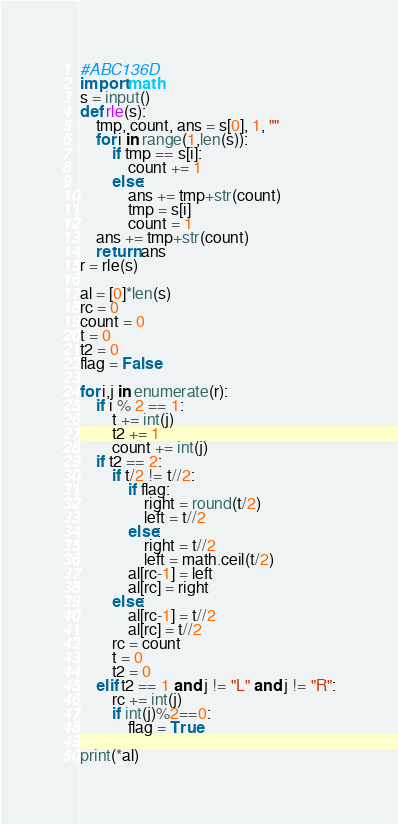<code> <loc_0><loc_0><loc_500><loc_500><_Python_>#ABC136D
import math
s = input()
def rle(s):
    tmp, count, ans = s[0], 1, ""
    for i in range(1,len(s)):
        if tmp == s[i]:
            count += 1
        else:
            ans += tmp+str(count)
            tmp = s[i]
            count = 1
    ans += tmp+str(count)
    return ans
r = rle(s)

al = [0]*len(s)
rc = 0
count = 0
t = 0
t2 = 0
flag = False

for i,j in enumerate(r):
    if i % 2 == 1:
        t += int(j)
        t2 += 1
        count += int(j)
    if t2 == 2:
        if t/2 != t//2:
            if flag:
                right = round(t/2)
                left = t//2
            else:
                right = t//2
                left = math.ceil(t/2)
            al[rc-1] = left
            al[rc] = right
        else:
            al[rc-1] = t//2
            al[rc] = t//2
        rc = count
        t = 0
        t2 = 0
    elif t2 == 1 and j != "L" and j != "R":
        rc += int(j)
        if int(j)%2==0:
            flag = True

print(*al)
</code> 